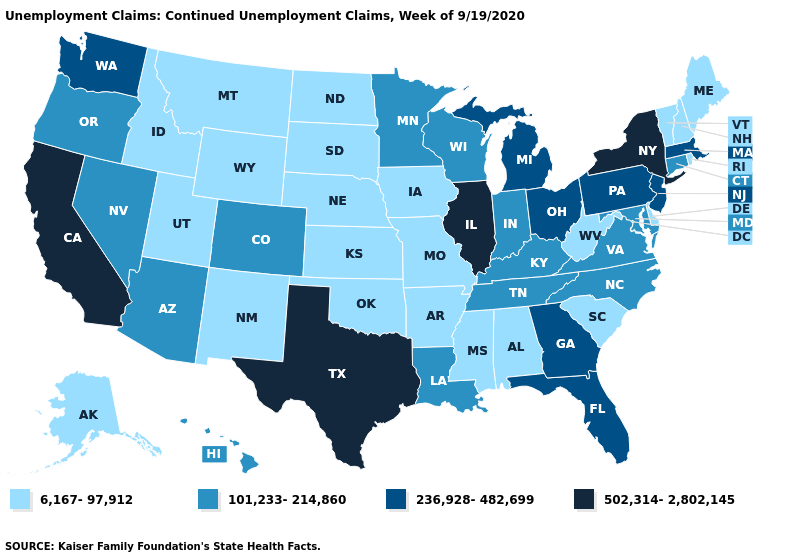Does California have the highest value in the USA?
Short answer required. Yes. Which states have the lowest value in the MidWest?
Keep it brief. Iowa, Kansas, Missouri, Nebraska, North Dakota, South Dakota. Name the states that have a value in the range 6,167-97,912?
Answer briefly. Alabama, Alaska, Arkansas, Delaware, Idaho, Iowa, Kansas, Maine, Mississippi, Missouri, Montana, Nebraska, New Hampshire, New Mexico, North Dakota, Oklahoma, Rhode Island, South Carolina, South Dakota, Utah, Vermont, West Virginia, Wyoming. What is the value of Texas?
Write a very short answer. 502,314-2,802,145. Does Illinois have a higher value than Nebraska?
Keep it brief. Yes. What is the value of Ohio?
Keep it brief. 236,928-482,699. Name the states that have a value in the range 502,314-2,802,145?
Give a very brief answer. California, Illinois, New York, Texas. What is the value of Montana?
Quick response, please. 6,167-97,912. Among the states that border Virginia , does West Virginia have the lowest value?
Answer briefly. Yes. Name the states that have a value in the range 6,167-97,912?
Keep it brief. Alabama, Alaska, Arkansas, Delaware, Idaho, Iowa, Kansas, Maine, Mississippi, Missouri, Montana, Nebraska, New Hampshire, New Mexico, North Dakota, Oklahoma, Rhode Island, South Carolina, South Dakota, Utah, Vermont, West Virginia, Wyoming. What is the value of Oklahoma?
Keep it brief. 6,167-97,912. Does the map have missing data?
Write a very short answer. No. Name the states that have a value in the range 236,928-482,699?
Answer briefly. Florida, Georgia, Massachusetts, Michigan, New Jersey, Ohio, Pennsylvania, Washington. Does Arizona have the highest value in the USA?
Short answer required. No. Among the states that border Utah , does Nevada have the highest value?
Short answer required. Yes. 